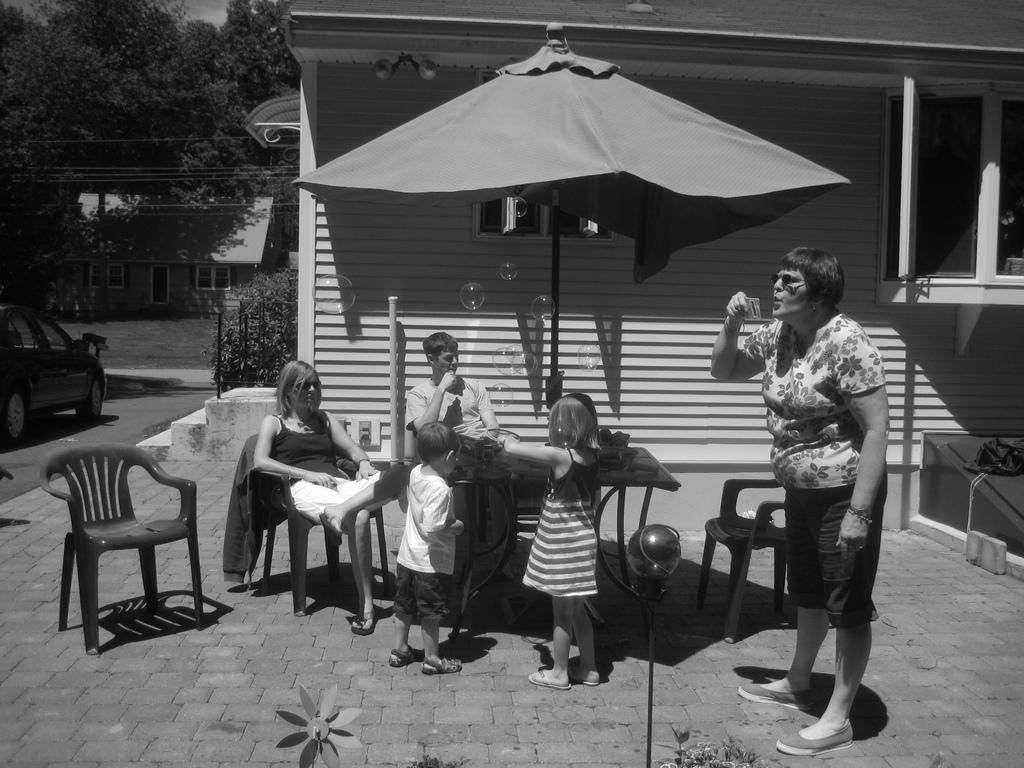Could you give a brief overview of what you see in this image? In this image I can see few people sitting and few are standing. Back I can see building,windows,tent,trees,wires,stairs and car on the road. I can see some objects on the table. The image is in black and white. 